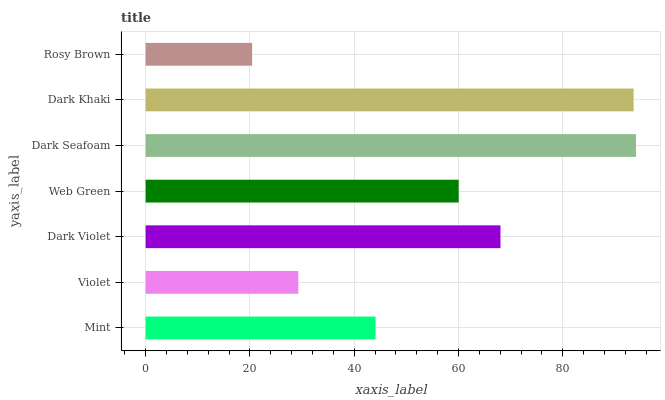Is Rosy Brown the minimum?
Answer yes or no. Yes. Is Dark Seafoam the maximum?
Answer yes or no. Yes. Is Violet the minimum?
Answer yes or no. No. Is Violet the maximum?
Answer yes or no. No. Is Mint greater than Violet?
Answer yes or no. Yes. Is Violet less than Mint?
Answer yes or no. Yes. Is Violet greater than Mint?
Answer yes or no. No. Is Mint less than Violet?
Answer yes or no. No. Is Web Green the high median?
Answer yes or no. Yes. Is Web Green the low median?
Answer yes or no. Yes. Is Dark Khaki the high median?
Answer yes or no. No. Is Dark Khaki the low median?
Answer yes or no. No. 